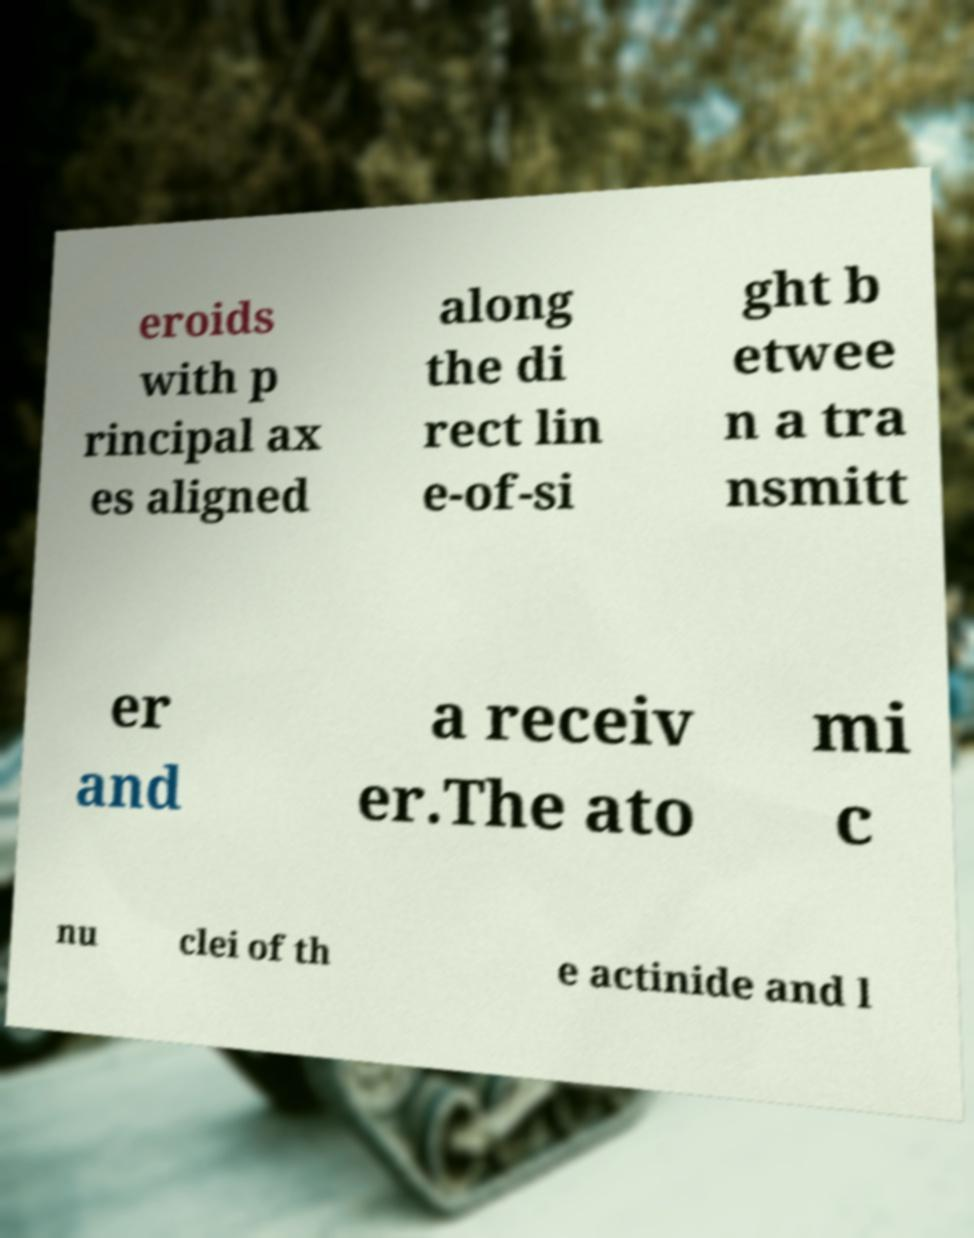I need the written content from this picture converted into text. Can you do that? eroids with p rincipal ax es aligned along the di rect lin e-of-si ght b etwee n a tra nsmitt er and a receiv er.The ato mi c nu clei of th e actinide and l 